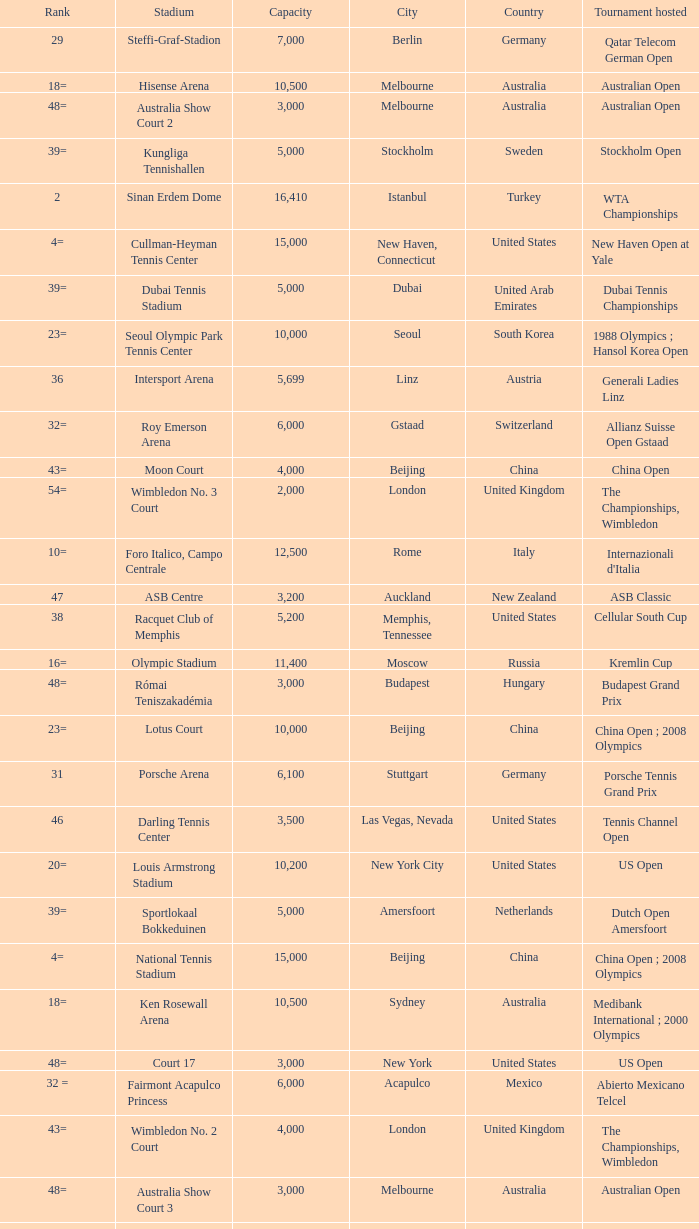What is the average capacity that has rod laver arena as the stadium? 14820.0. 